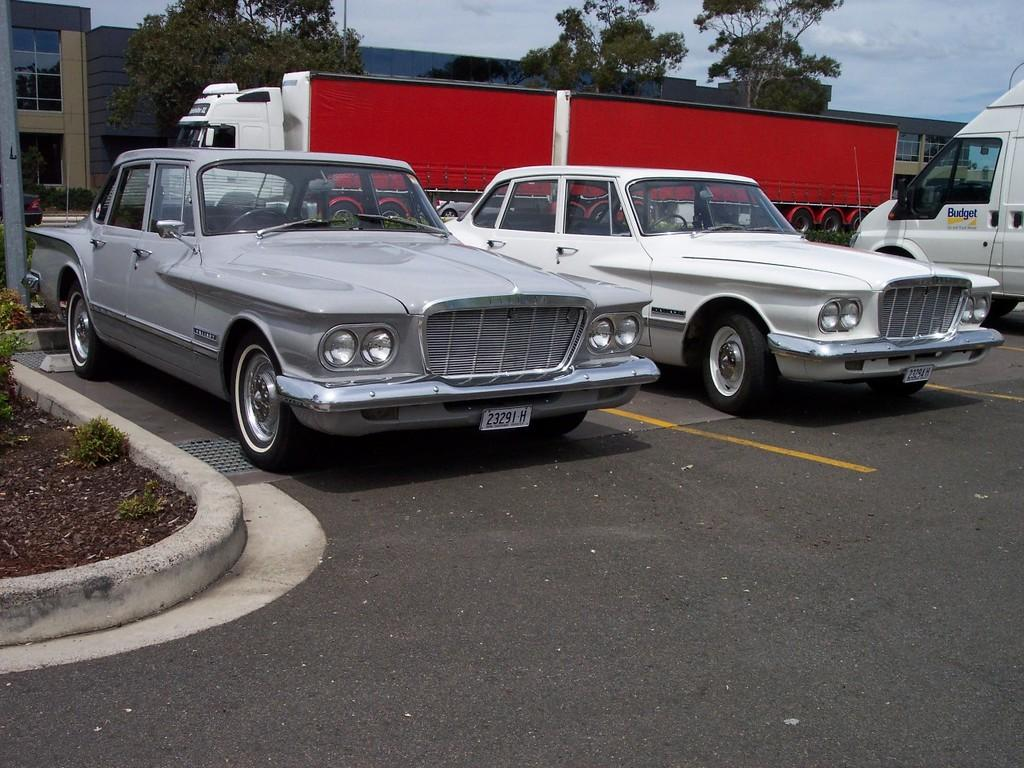What type of structures can be seen in the image? There are buildings in the image. What is located in front of the buildings? Trees are present in front of the buildings. What can be seen on the road in the image? There are vehicles parked on the road. What is on the left side of the image? There is a pole and plants on the left side of the image. Can you tell me how many bulbs are hanging from the pole in the image? There is no mention of bulbs in the image; the pole is the only object mentioned on the left side. Is there a river flowing through the buildings in the image? There is no river present in the image; only buildings, trees, vehicles, a pole, and plants are mentioned. 